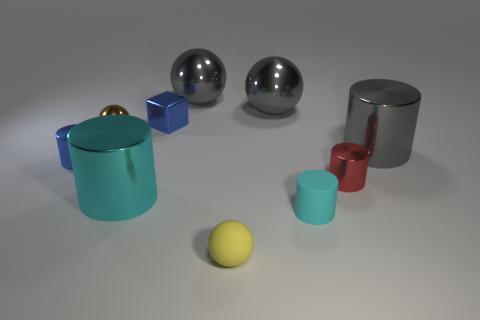What number of other things are made of the same material as the blue block?
Keep it short and to the point. 7. There is a blue block that is the same size as the brown metal thing; what material is it?
Ensure brevity in your answer.  Metal. There is a tiny matte thing that is in front of the small cyan matte thing; is it the same shape as the brown shiny object?
Offer a very short reply. Yes. Does the tiny metal cube have the same color as the tiny rubber ball?
Your response must be concise. No. What number of things are either big gray metallic things that are right of the yellow ball or blue objects?
Give a very brief answer. 4. What shape is the cyan rubber thing that is the same size as the matte ball?
Offer a terse response. Cylinder. There is a metallic ball right of the small yellow object; is its size the same as the cyan cylinder that is left of the matte sphere?
Make the answer very short. Yes. What color is the small ball that is the same material as the tiny blue cube?
Offer a very short reply. Brown. Is the large cylinder that is on the left side of the tiny red metallic object made of the same material as the small sphere that is to the right of the brown object?
Offer a terse response. No. Is there a purple cube that has the same size as the red metal cylinder?
Keep it short and to the point. No. 